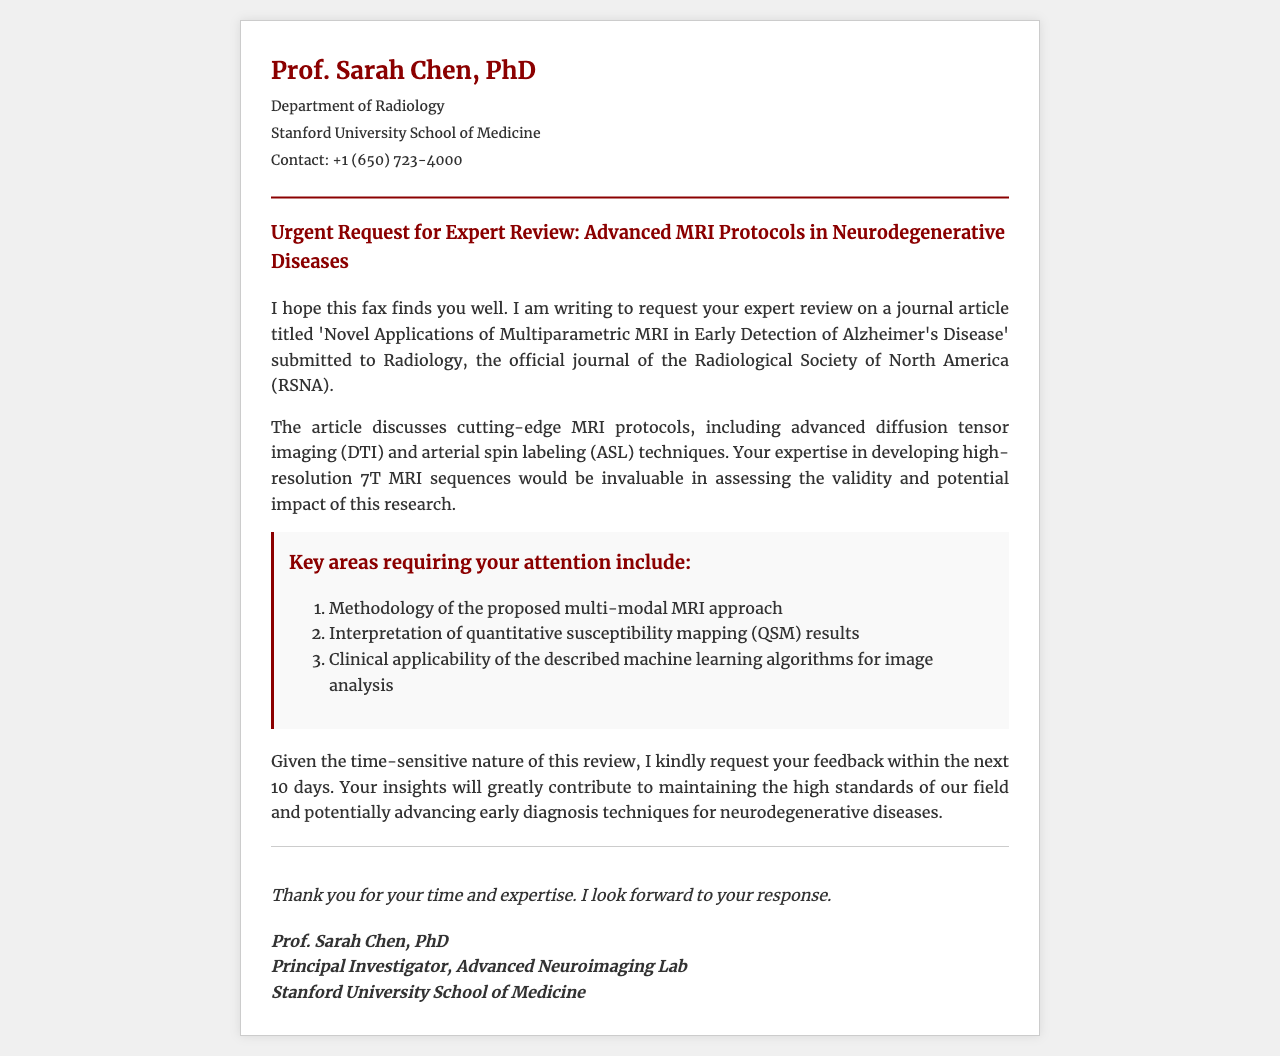What is the name of the institution? The name of the institution is provided in the document as Stanford University School of Medicine.
Answer: Stanford University School of Medicine Who is making the request? The request is made by Prof. Sarah Chen, as identified in the header of the document.
Answer: Prof. Sarah Chen What is the title of the article under review? The title of the article is included in the body of the document and indicates its subject matter.
Answer: Novel Applications of Multiparametric MRI in Early Detection of Alzheimer's Disease What specific techniques are discussed in the article? The document mentions advanced imaging techniques that are part of the article's subject.
Answer: diffusion tensor imaging and arterial spin labeling How many key areas are outlined for the expert review? The number of key areas requiring attention is listed in the key-areas section of the document.
Answer: Three What is the requested feedback timeframe? The document specifies how quickly feedback is needed for the review process.
Answer: 10 days What is the main focus of the research in the article? The document highlights the central theme of the research, which is related to a specific disease.
Answer: Alzheimer's Disease In which journal was the article submitted? The journal to which the article has been submitted is mentioned in the document's body.
Answer: Radiology What position does Prof. Sarah Chen hold? The document states Prof. Sarah Chen's role in the Advanced Neuroimaging Lab, indicating her professional level.
Answer: Principal Investigator 